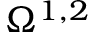<formula> <loc_0><loc_0><loc_500><loc_500>\Omega ^ { 1 , 2 }</formula> 